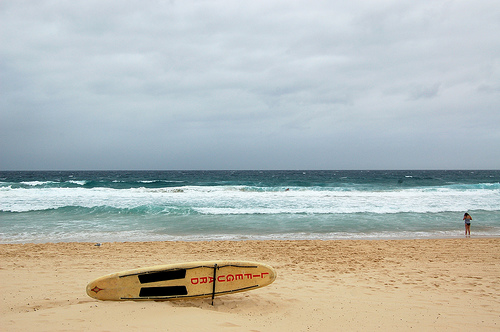<image>What vehicle is parked in front of the rock? I don't know what vehicle is parked in front of the rock. It can be a surfboard, car, or a paddle board. What vehicle is parked in front of the rock? There is no rock in the image. However, a surfboard is parked in front of the rock. 